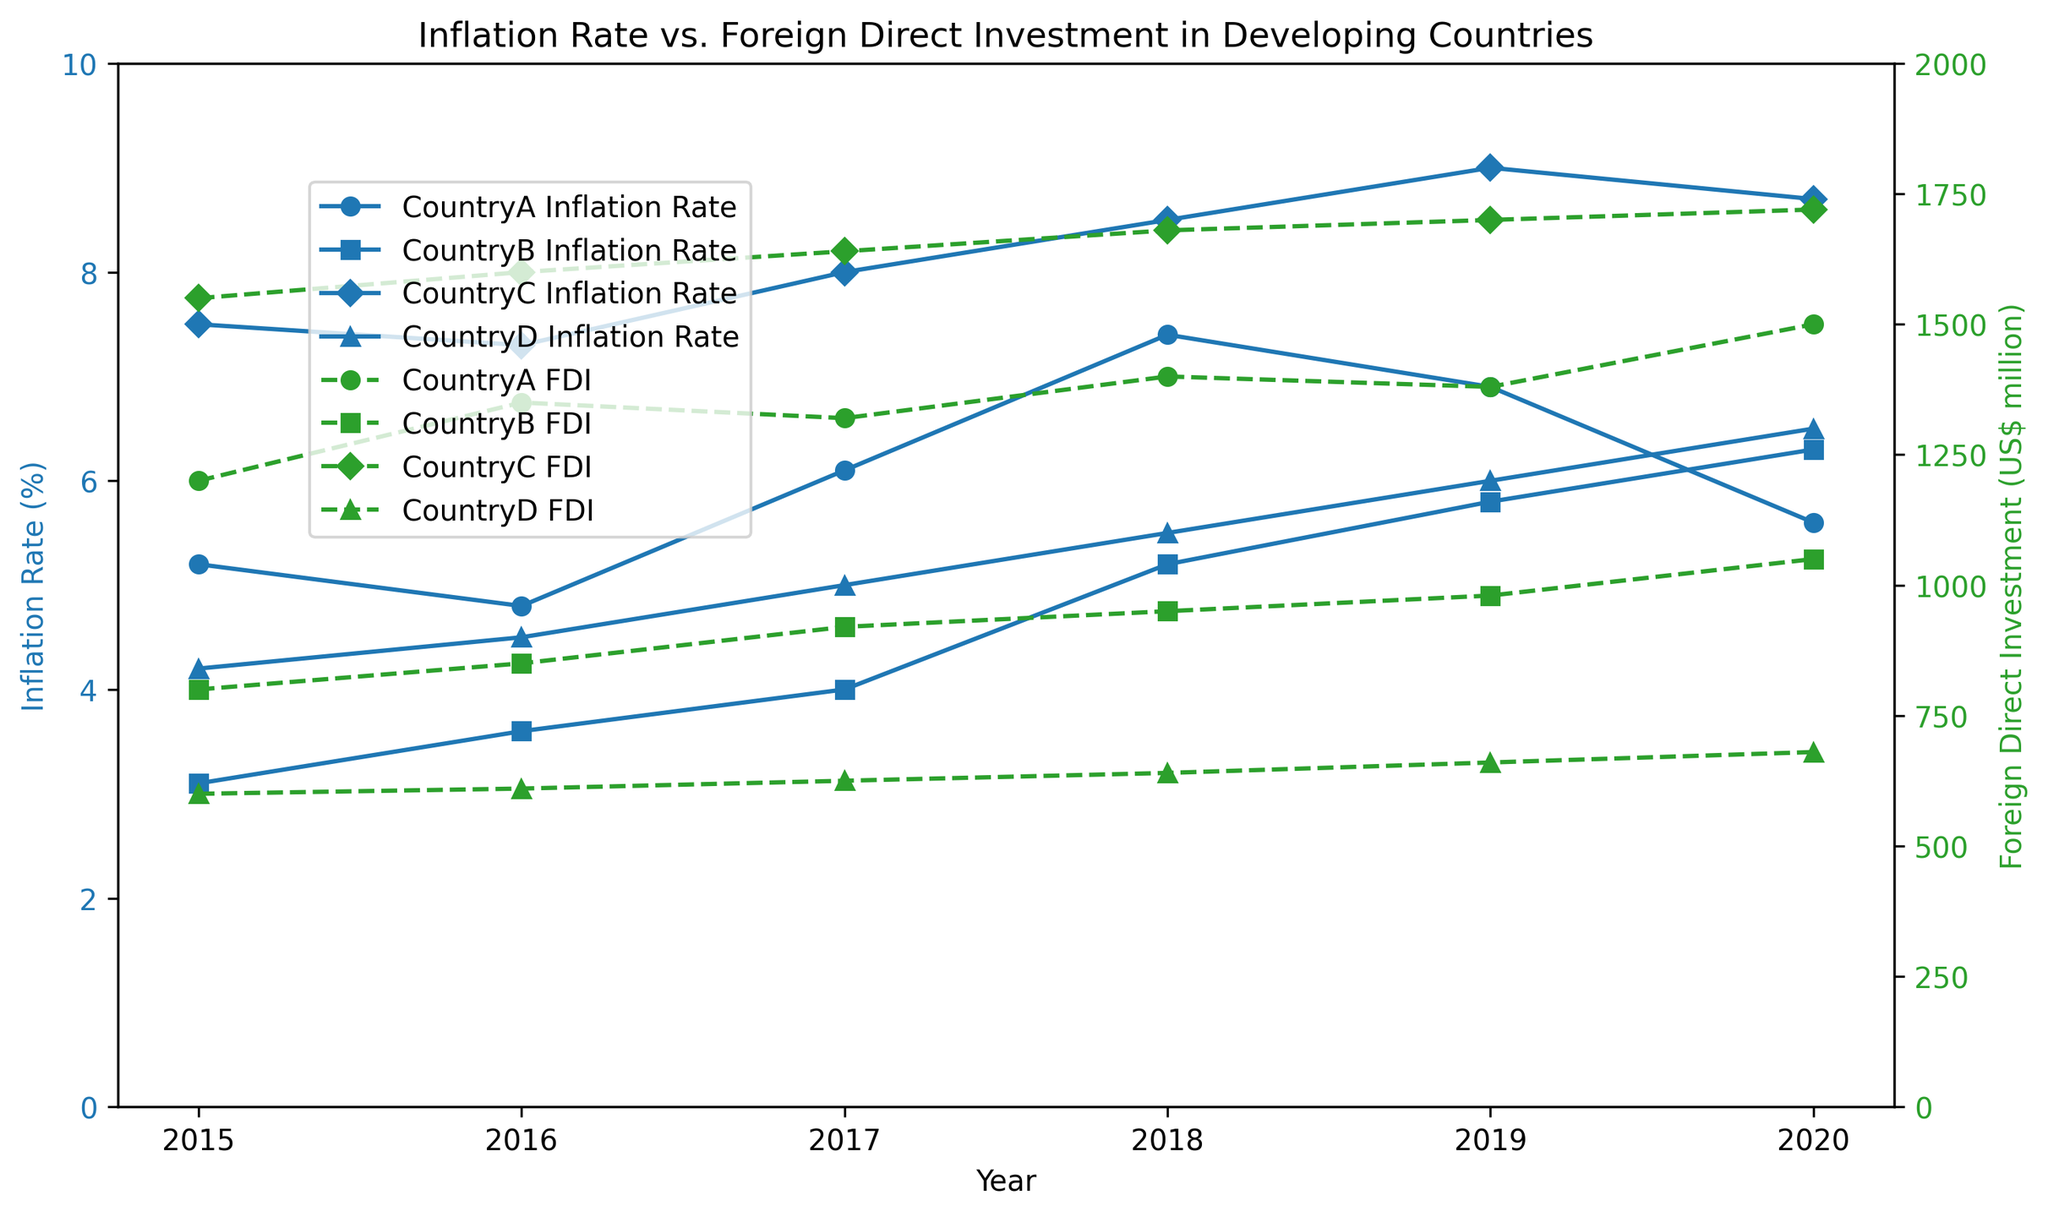Which country had the highest inflation rate in 2020? Identify the inflation rates for all countries in 2020 and compare them. CountryC had an inflation rate of 8.7%, which is the highest among all.
Answer: CountryC Did CountryA have a consistent increase in FDI from 2015 to 2020? Plot the FDI values for CountryA from 2015 to 2020 and observe the trend. The FDI increased from 1200 in 2015 to 1500 in 2020, although it slightly decreased in 2017 and 2019.
Answer: No Which country experienced the largest decrease in inflation rate between any two consecutive years? Compare the differences in inflation rates between consecutive years for all countries. CountryA had the largest decrease from 7.4% in 2018 to 6.9% in 2019, a difference of 0.5%.
Answer: CountryA Compare the inflation rate trends of CountryB and CountryD from 2015 to 2020. Observe the inflation rate curves for both countries from 2015 to 2020. Both CountryB and CountryD show an increasing trend in inflation rates, but CountryB's rate rises from 3.1% to 6.3%, while CountryD's rate rises from 4.2% to 6.5%.
Answer: Both increase Among the countries, which one had the lowest FDI in 2015, and what was its value? Identify the FDI values for all countries in 2015 and find the lowest. CountryD had the lowest FDI in 2015 with a value of 600.
Answer: CountryD, 600 